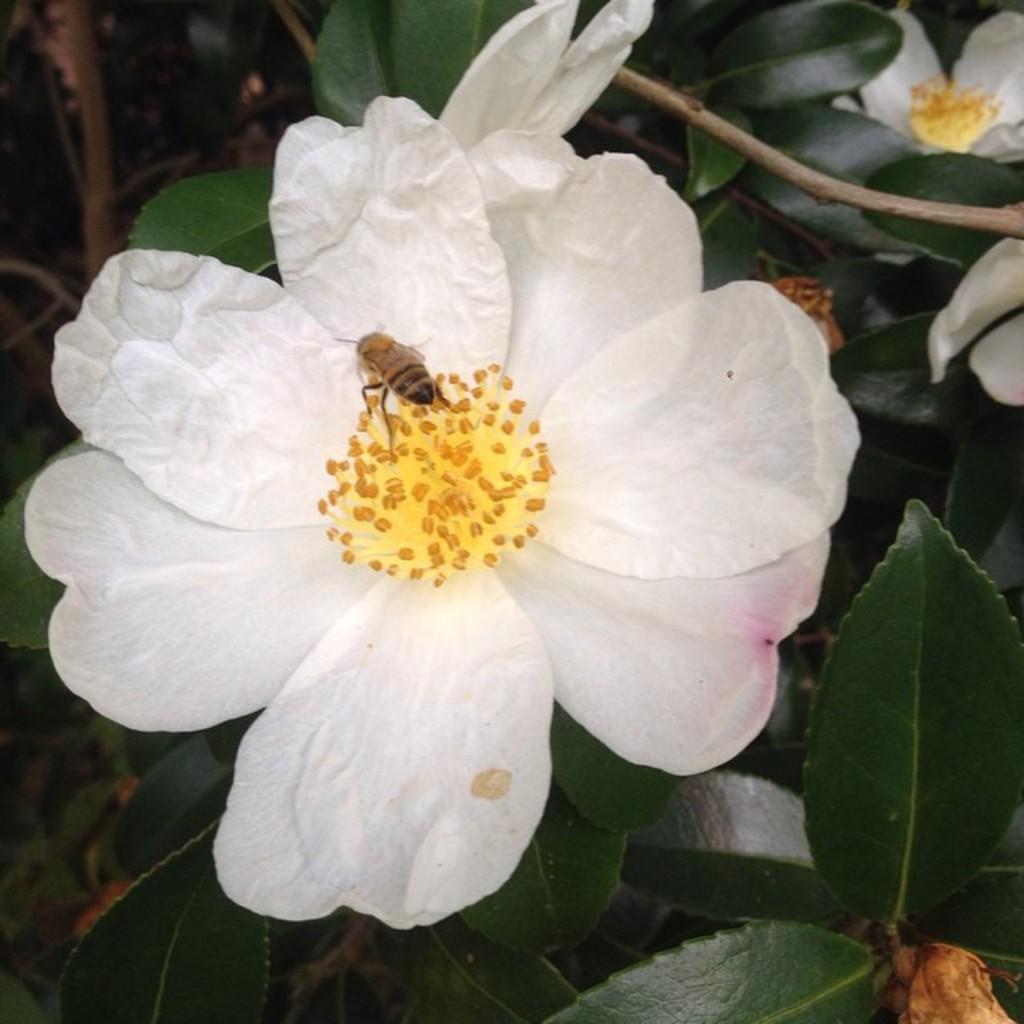How would you summarize this image in a sentence or two? In this image there is a bee sitting on flower which is on the plant. 